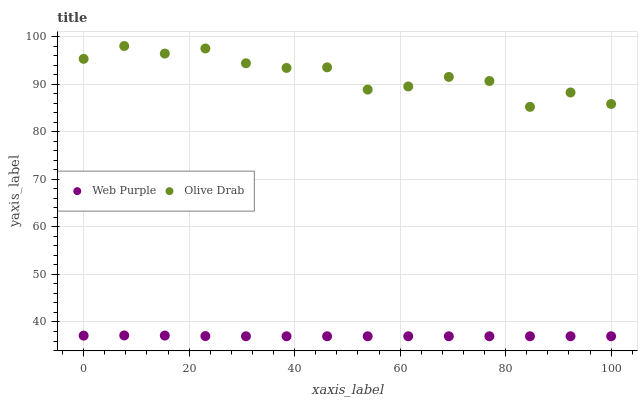Does Web Purple have the minimum area under the curve?
Answer yes or no. Yes. Does Olive Drab have the maximum area under the curve?
Answer yes or no. Yes. Does Olive Drab have the minimum area under the curve?
Answer yes or no. No. Is Web Purple the smoothest?
Answer yes or no. Yes. Is Olive Drab the roughest?
Answer yes or no. Yes. Is Olive Drab the smoothest?
Answer yes or no. No. Does Web Purple have the lowest value?
Answer yes or no. Yes. Does Olive Drab have the lowest value?
Answer yes or no. No. Does Olive Drab have the highest value?
Answer yes or no. Yes. Is Web Purple less than Olive Drab?
Answer yes or no. Yes. Is Olive Drab greater than Web Purple?
Answer yes or no. Yes. Does Web Purple intersect Olive Drab?
Answer yes or no. No. 